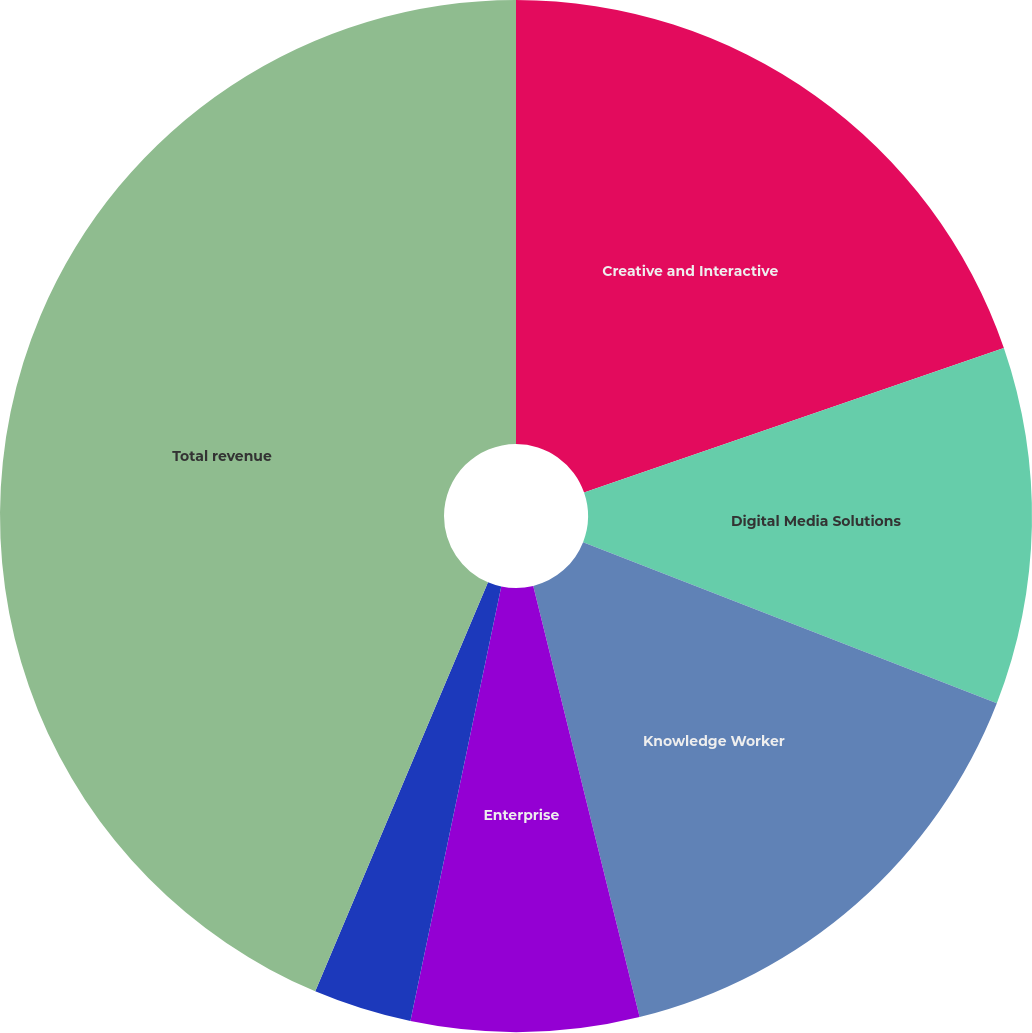<chart> <loc_0><loc_0><loc_500><loc_500><pie_chart><fcel>Creative and Interactive<fcel>Digital Media Solutions<fcel>Knowledge Worker<fcel>Enterprise<fcel>Print and Publishing<fcel>Total revenue<nl><fcel>19.72%<fcel>11.19%<fcel>15.24%<fcel>7.13%<fcel>3.08%<fcel>43.64%<nl></chart> 